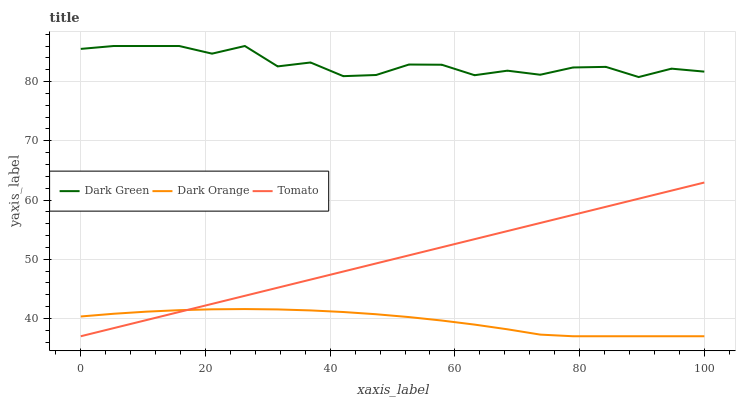Does Dark Orange have the minimum area under the curve?
Answer yes or no. Yes. Does Dark Green have the maximum area under the curve?
Answer yes or no. Yes. Does Dark Green have the minimum area under the curve?
Answer yes or no. No. Does Dark Orange have the maximum area under the curve?
Answer yes or no. No. Is Tomato the smoothest?
Answer yes or no. Yes. Is Dark Green the roughest?
Answer yes or no. Yes. Is Dark Orange the smoothest?
Answer yes or no. No. Is Dark Orange the roughest?
Answer yes or no. No. Does Tomato have the lowest value?
Answer yes or no. Yes. Does Dark Green have the lowest value?
Answer yes or no. No. Does Dark Green have the highest value?
Answer yes or no. Yes. Does Dark Orange have the highest value?
Answer yes or no. No. Is Dark Orange less than Dark Green?
Answer yes or no. Yes. Is Dark Green greater than Tomato?
Answer yes or no. Yes. Does Dark Orange intersect Tomato?
Answer yes or no. Yes. Is Dark Orange less than Tomato?
Answer yes or no. No. Is Dark Orange greater than Tomato?
Answer yes or no. No. Does Dark Orange intersect Dark Green?
Answer yes or no. No. 